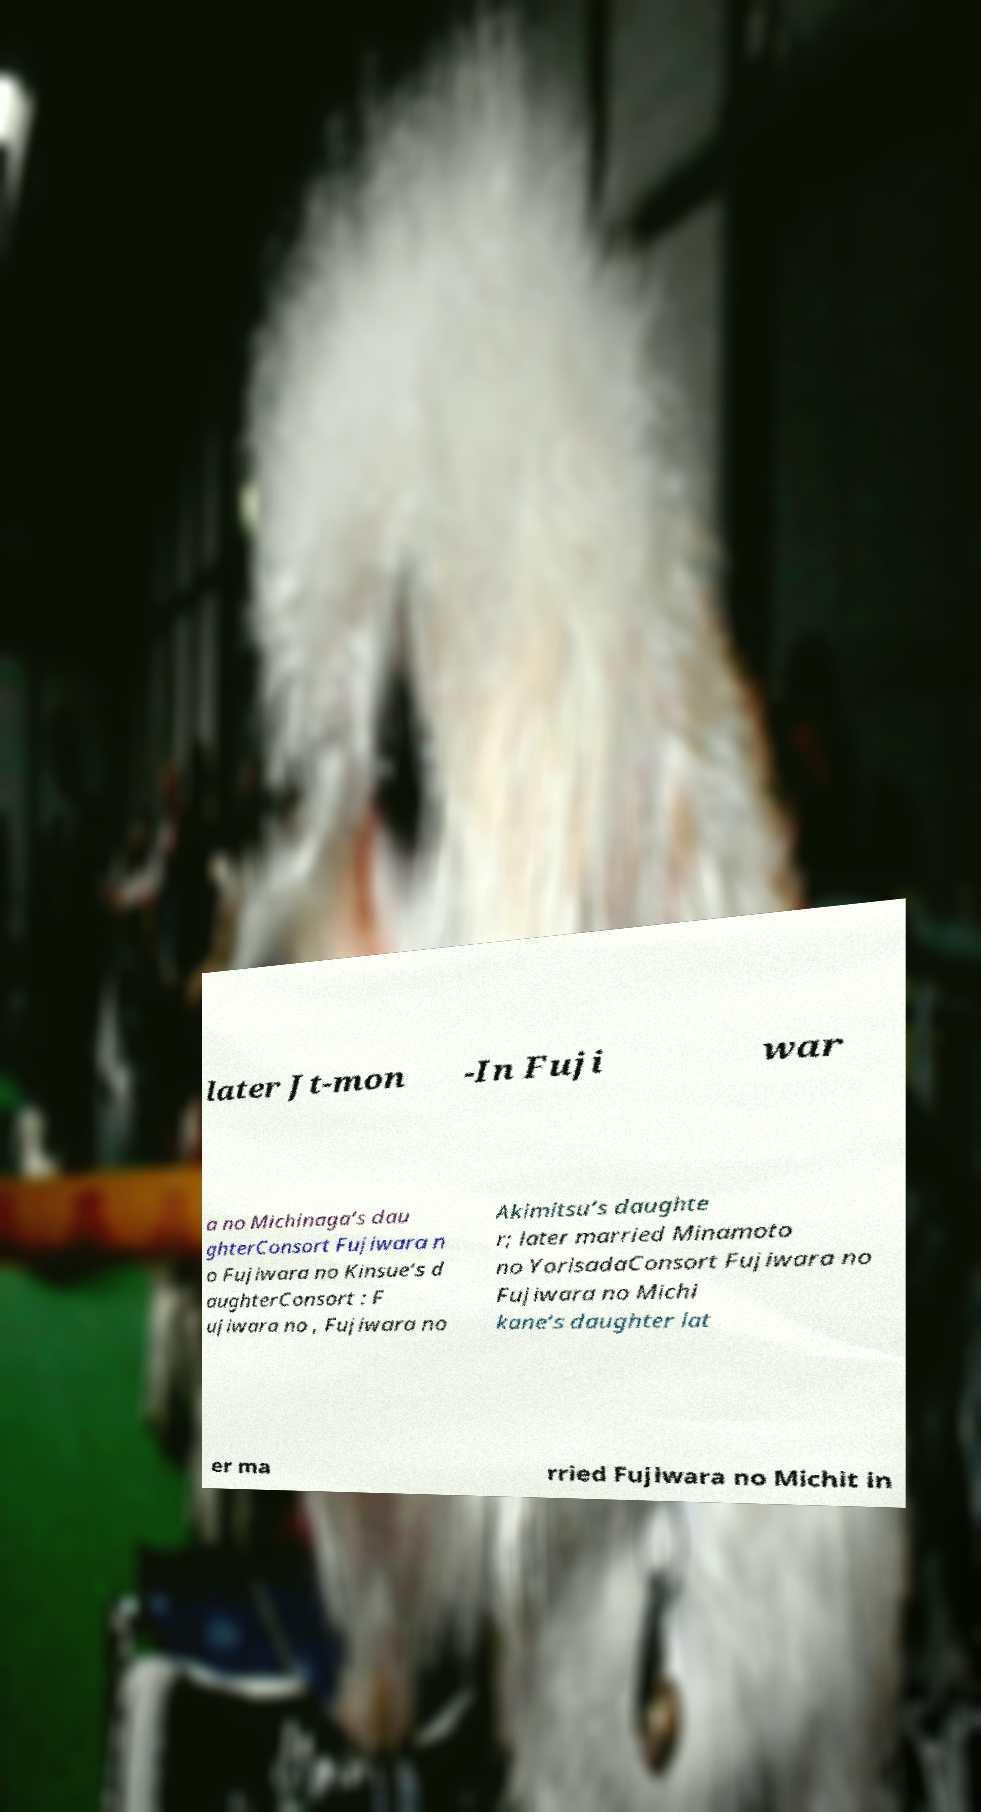Please identify and transcribe the text found in this image. later Jt-mon -In Fuji war a no Michinaga‘s dau ghterConsort Fujiwara n o Fujiwara no Kinsue‘s d aughterConsort : F ujiwara no , Fujiwara no Akimitsu‘s daughte r; later married Minamoto no YorisadaConsort Fujiwara no Fujiwara no Michi kane‘s daughter lat er ma rried Fujiwara no Michit in 